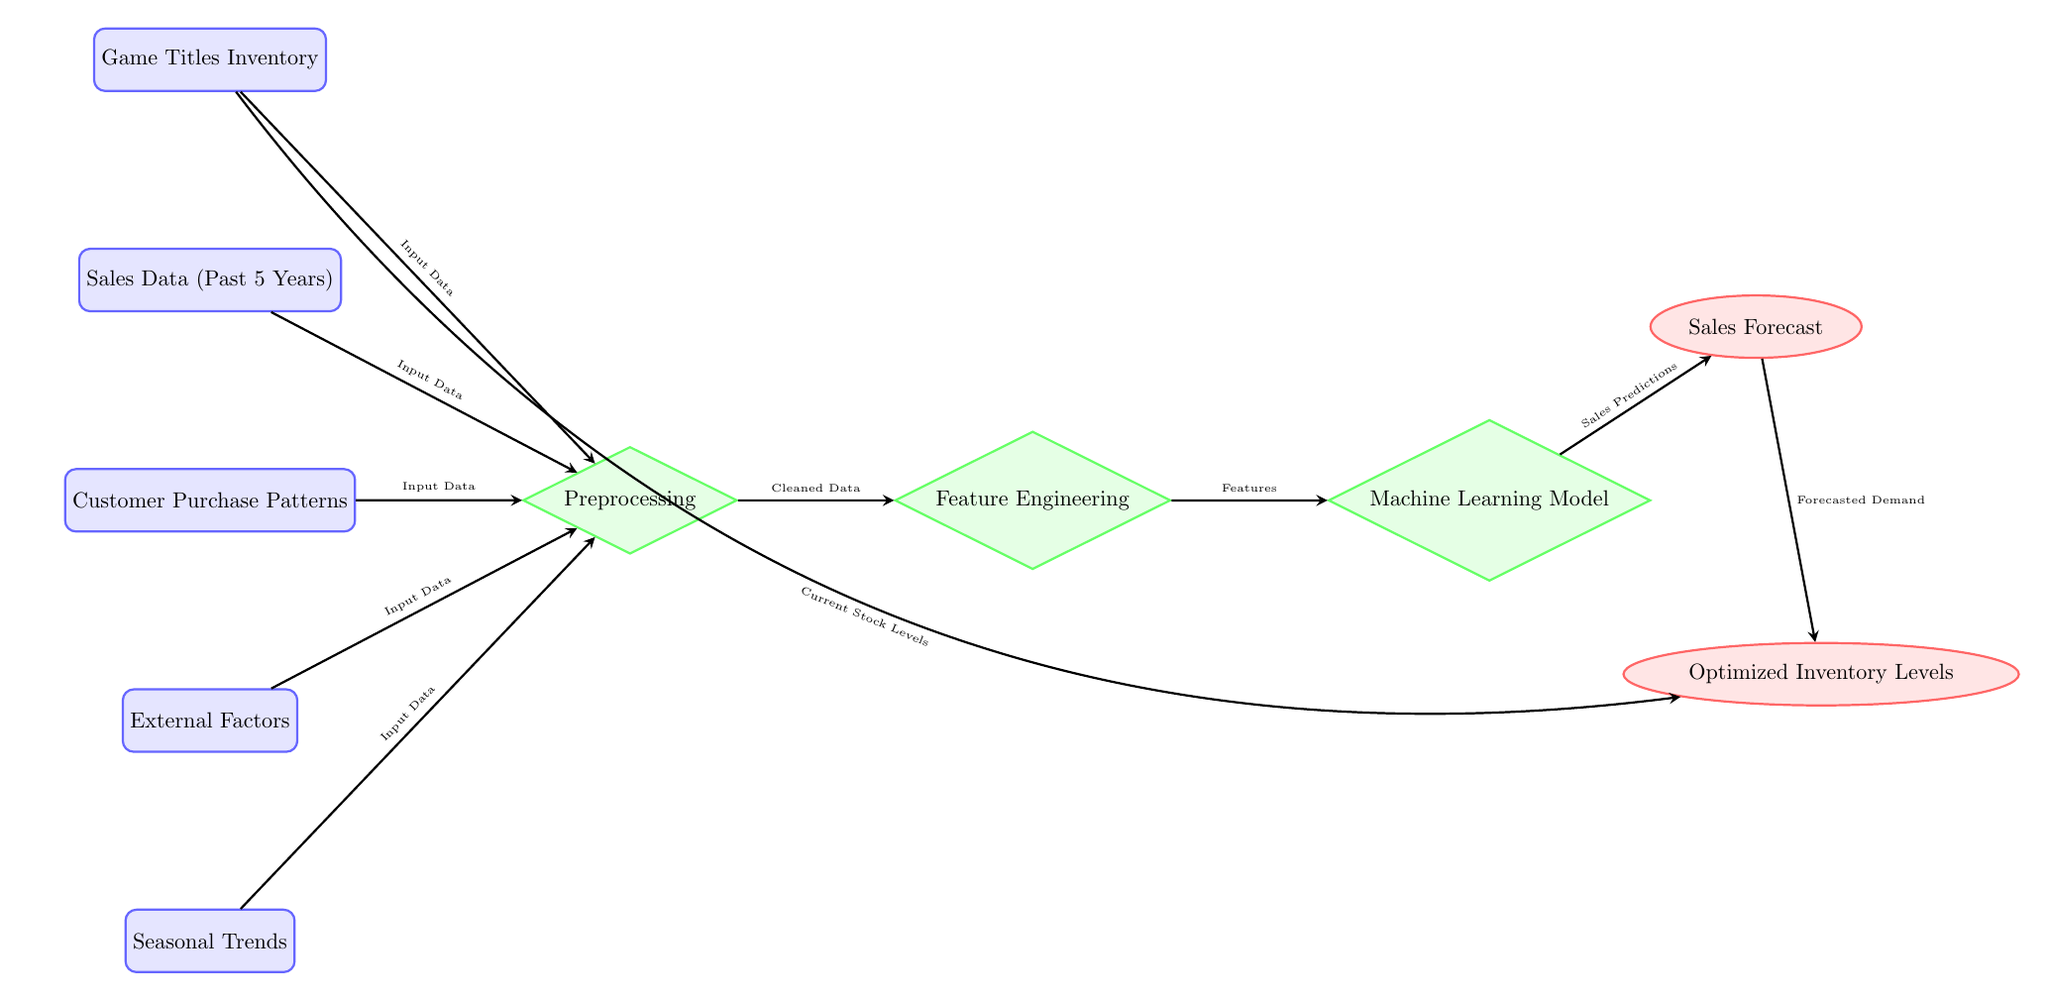What are the nodes representing inventory data in the diagram? The nodes representing inventory data include "Game Titles Inventory" and "Current Stock Levels." "Game Titles Inventory" is a data node that contributes to the input, while "Current Stock Levels" is an input to the output node "Optimized Inventory Levels."
Answer: Game Titles Inventory, Current Stock Levels How many data nodes are present in the diagram? The diagram contains five distinct data nodes: "Game Titles Inventory," "Sales Data (Past 5 Years)," "Customer Purchase Patterns," "External Factors," and "Seasonal Trends."
Answer: 5 What is the output generated after the "Machine Learning Model" process? After the "Machine Learning Model" process, the outputs generated are "Sales Forecast" and "Optimized Inventory Levels." The model predicts sales that flow to the "Sales Forecast" output and informs the next step for inventory optimization.
Answer: Sales Forecast, Optimized Inventory Levels Which node receives cleaned data as input? The node that receives cleaned data as input is the "Feature Engineering" node. It follows the "Preprocessing" node, which cleans the input data before passing it on.
Answer: Feature Engineering What influences the "Optimized Inventory Levels"? "Optimized Inventory Levels" is influenced by "Forecasted Demand" from the "Sales Forecast" output and "Current Stock Levels," which indicates the present inventory status.
Answer: Forecasted Demand, Current Stock Levels What is the process prior to "Feature Engineering"? The process that occurs before "Feature Engineering" is "Preprocessing." This step is essential for preparing the raw data for feature extraction and modeling.
Answer: Preprocessing How many types of nodes are present in this diagram? The diagram features three types of nodes—the data nodes, which represent the input data; the process nodes, which indicate processing stages; and the output nodes, which show the result of the analysis.
Answer: 3 Which external factors are considered in the model? The "External Factors" node in the diagram specifically indicates that the model incorporates various outside elements that can impact sales forecasting and inventory management, though the specifics are not detailed in the diagram.
Answer: External Factors What data sources are combined for input into preprocessing? The data sources combined for input into preprocessing are "Game Titles Inventory," "Sales Data (Past 5 Years)," "Customer Purchase Patterns," "External Factors," and "Seasonal Trends." All these data nodes contribute essential insights for the preprocessing stage.
Answer: Game Titles Inventory, Sales Data (Past 5 Years), Customer Purchase Patterns, External Factors, Seasonal Trends 